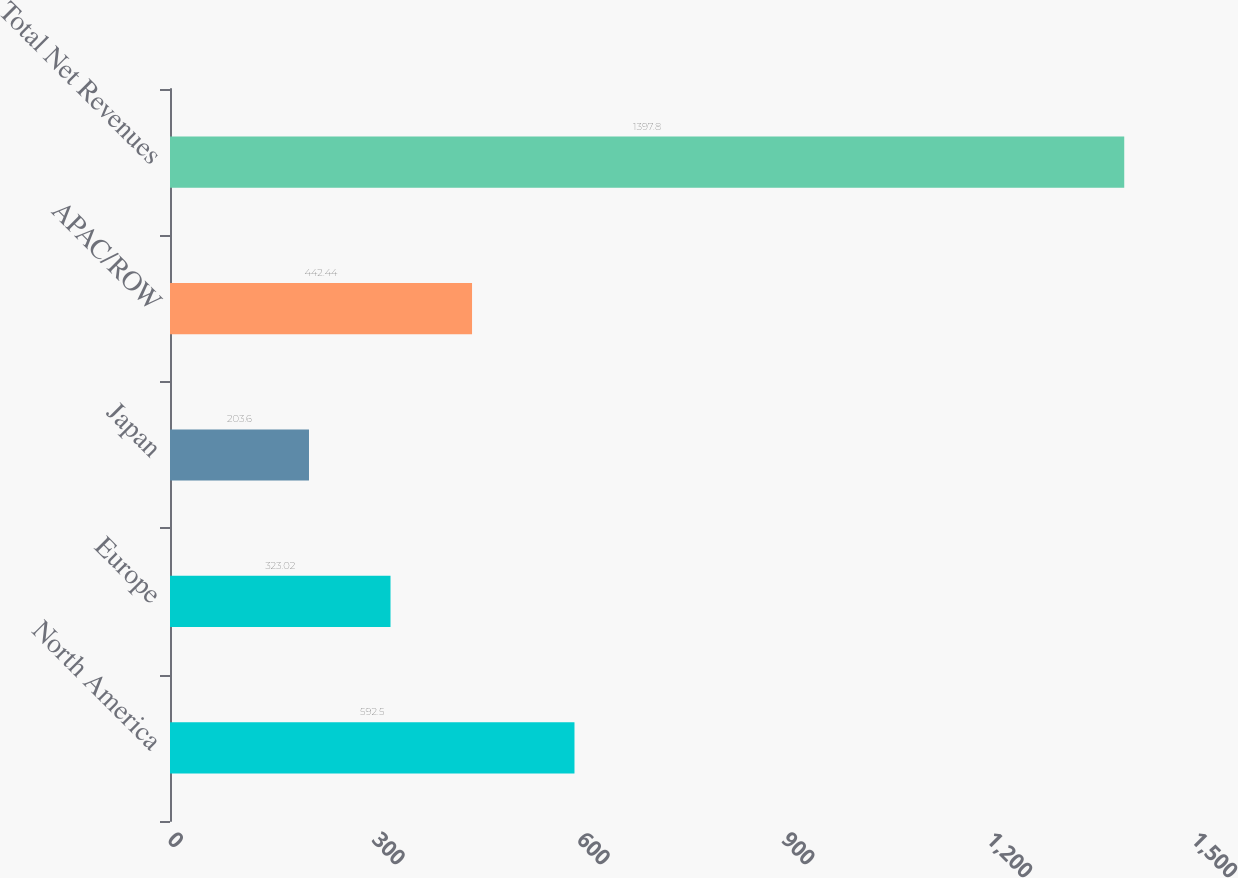Convert chart to OTSL. <chart><loc_0><loc_0><loc_500><loc_500><bar_chart><fcel>North America<fcel>Europe<fcel>Japan<fcel>APAC/ROW<fcel>Total Net Revenues<nl><fcel>592.5<fcel>323.02<fcel>203.6<fcel>442.44<fcel>1397.8<nl></chart> 